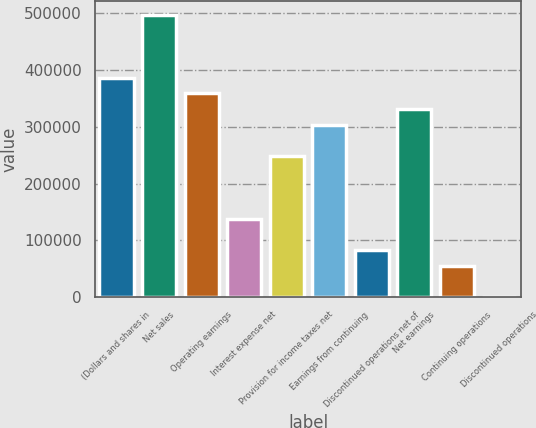Convert chart. <chart><loc_0><loc_0><loc_500><loc_500><bar_chart><fcel>(Dollars and shares in<fcel>Net sales<fcel>Operating earnings<fcel>Interest expense net<fcel>Provision for income taxes net<fcel>Earnings from continuing<fcel>Discontinued operations net of<fcel>Net earnings<fcel>Continuing operations<fcel>Discontinued operations<nl><fcel>386400<fcel>496800<fcel>358800<fcel>138000<fcel>248400<fcel>303600<fcel>82800.1<fcel>331200<fcel>55200.1<fcel>0.13<nl></chart> 